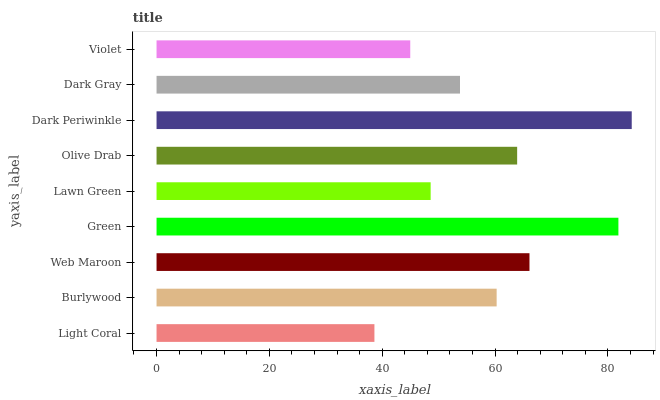Is Light Coral the minimum?
Answer yes or no. Yes. Is Dark Periwinkle the maximum?
Answer yes or no. Yes. Is Burlywood the minimum?
Answer yes or no. No. Is Burlywood the maximum?
Answer yes or no. No. Is Burlywood greater than Light Coral?
Answer yes or no. Yes. Is Light Coral less than Burlywood?
Answer yes or no. Yes. Is Light Coral greater than Burlywood?
Answer yes or no. No. Is Burlywood less than Light Coral?
Answer yes or no. No. Is Burlywood the high median?
Answer yes or no. Yes. Is Burlywood the low median?
Answer yes or no. Yes. Is Dark Gray the high median?
Answer yes or no. No. Is Web Maroon the low median?
Answer yes or no. No. 